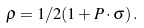<formula> <loc_0><loc_0><loc_500><loc_500>\rho = 1 / 2 ( 1 + { P } \cdot { \sigma } ) \, .</formula> 